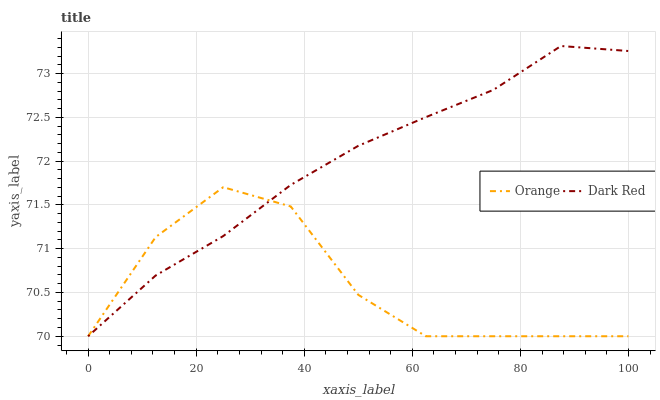Does Orange have the minimum area under the curve?
Answer yes or no. Yes. Does Dark Red have the maximum area under the curve?
Answer yes or no. Yes. Does Dark Red have the minimum area under the curve?
Answer yes or no. No. Is Dark Red the smoothest?
Answer yes or no. Yes. Is Orange the roughest?
Answer yes or no. Yes. Is Dark Red the roughest?
Answer yes or no. No. Does Orange have the lowest value?
Answer yes or no. Yes. Does Dark Red have the highest value?
Answer yes or no. Yes. Does Orange intersect Dark Red?
Answer yes or no. Yes. Is Orange less than Dark Red?
Answer yes or no. No. Is Orange greater than Dark Red?
Answer yes or no. No. 